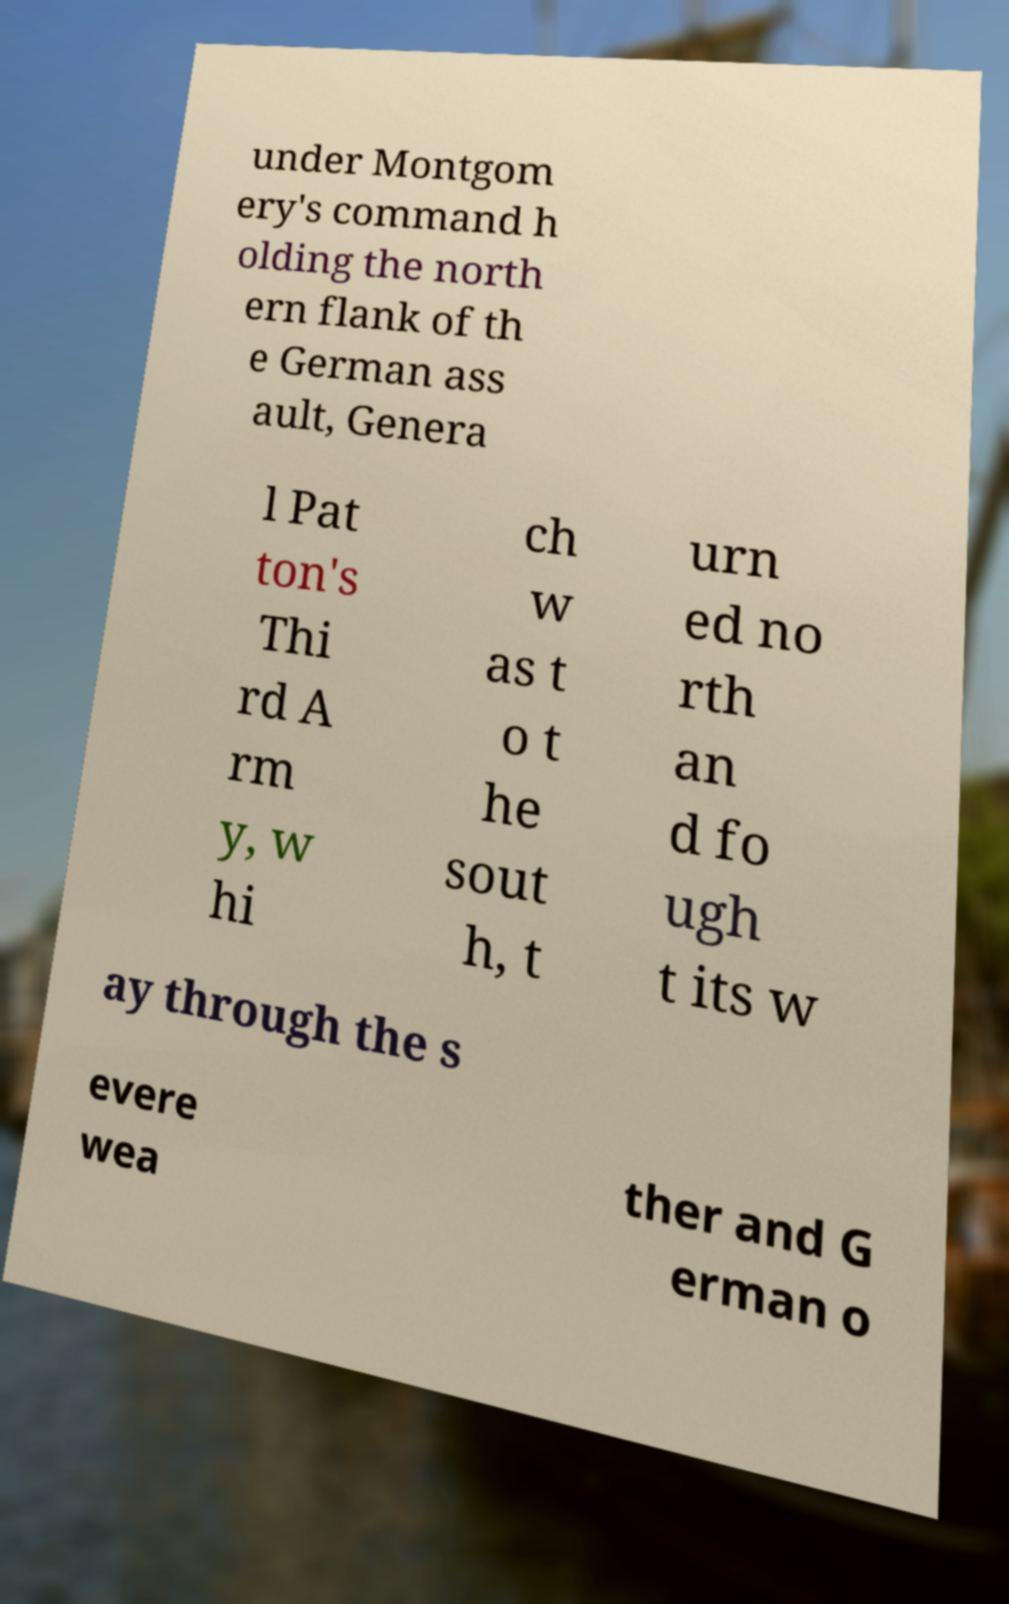Please read and relay the text visible in this image. What does it say? under Montgom ery's command h olding the north ern flank of th e German ass ault, Genera l Pat ton's Thi rd A rm y, w hi ch w as t o t he sout h, t urn ed no rth an d fo ugh t its w ay through the s evere wea ther and G erman o 